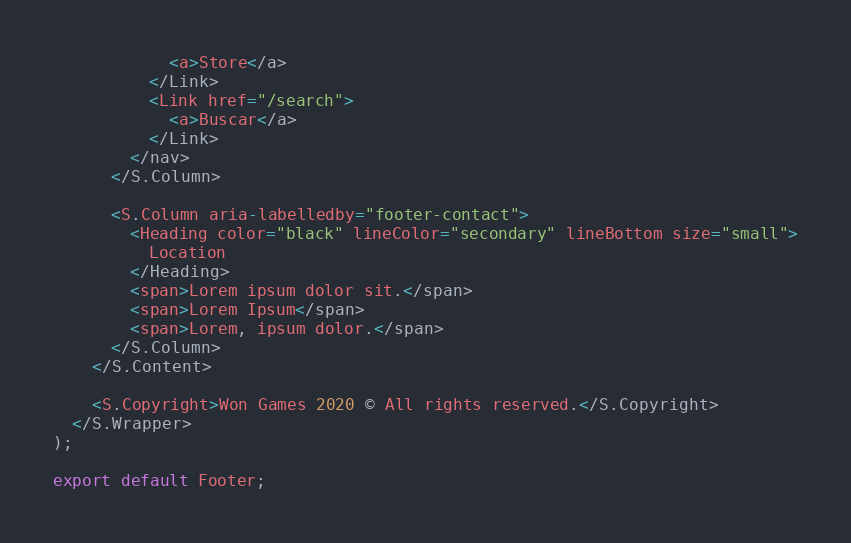<code> <loc_0><loc_0><loc_500><loc_500><_TypeScript_>            <a>Store</a>
          </Link>
          <Link href="/search">
            <a>Buscar</a>
          </Link>
        </nav>
      </S.Column>

      <S.Column aria-labelledby="footer-contact">
        <Heading color="black" lineColor="secondary" lineBottom size="small">
          Location
        </Heading>
        <span>Lorem ipsum dolor sit.</span>
        <span>Lorem Ipsum</span>
        <span>Lorem, ipsum dolor.</span>
      </S.Column>
    </S.Content>

    <S.Copyright>Won Games 2020 © All rights reserved.</S.Copyright>
  </S.Wrapper>
);

export default Footer;
</code> 